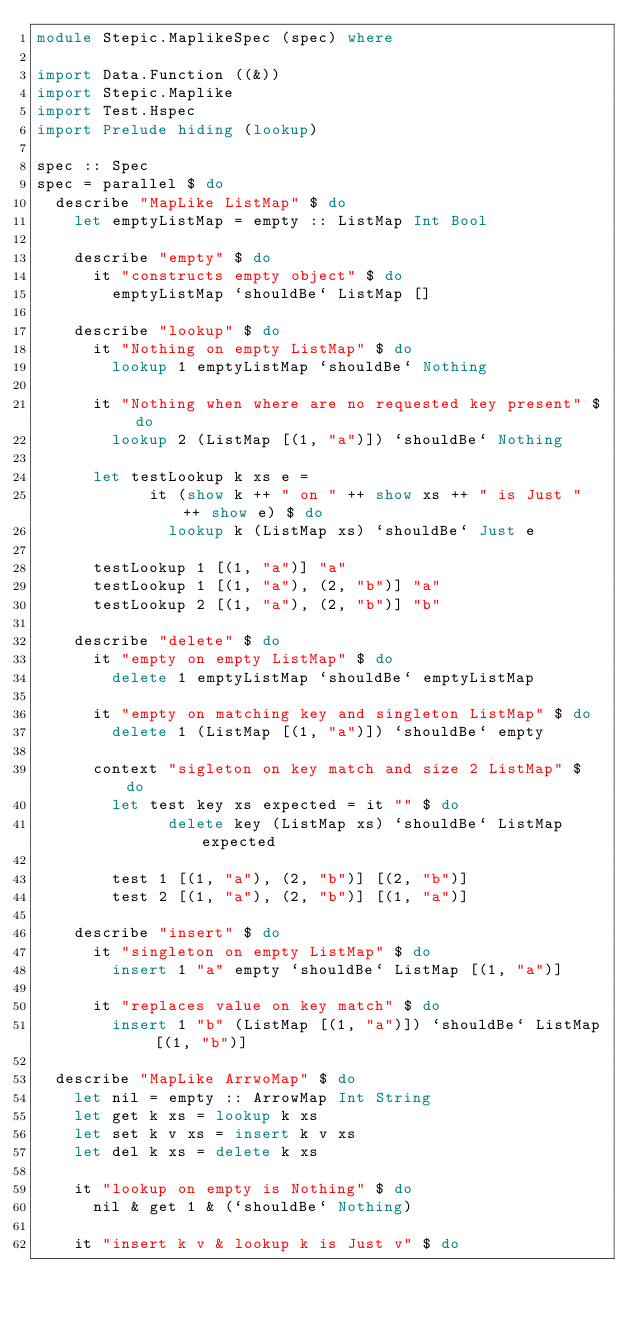Convert code to text. <code><loc_0><loc_0><loc_500><loc_500><_Haskell_>module Stepic.MaplikeSpec (spec) where

import Data.Function ((&))
import Stepic.Maplike
import Test.Hspec
import Prelude hiding (lookup)

spec :: Spec
spec = parallel $ do
  describe "MapLike ListMap" $ do
    let emptyListMap = empty :: ListMap Int Bool

    describe "empty" $ do
      it "constructs empty object" $ do
        emptyListMap `shouldBe` ListMap []

    describe "lookup" $ do
      it "Nothing on empty ListMap" $ do
        lookup 1 emptyListMap `shouldBe` Nothing

      it "Nothing when where are no requested key present" $ do
        lookup 2 (ListMap [(1, "a")]) `shouldBe` Nothing

      let testLookup k xs e =
            it (show k ++ " on " ++ show xs ++ " is Just " ++ show e) $ do
              lookup k (ListMap xs) `shouldBe` Just e

      testLookup 1 [(1, "a")] "a"
      testLookup 1 [(1, "a"), (2, "b")] "a"
      testLookup 2 [(1, "a"), (2, "b")] "b"

    describe "delete" $ do
      it "empty on empty ListMap" $ do
        delete 1 emptyListMap `shouldBe` emptyListMap

      it "empty on matching key and singleton ListMap" $ do
        delete 1 (ListMap [(1, "a")]) `shouldBe` empty

      context "sigleton on key match and size 2 ListMap" $ do
        let test key xs expected = it "" $ do
              delete key (ListMap xs) `shouldBe` ListMap expected

        test 1 [(1, "a"), (2, "b")] [(2, "b")]
        test 2 [(1, "a"), (2, "b")] [(1, "a")]

    describe "insert" $ do
      it "singleton on empty ListMap" $ do
        insert 1 "a" empty `shouldBe` ListMap [(1, "a")]

      it "replaces value on key match" $ do
        insert 1 "b" (ListMap [(1, "a")]) `shouldBe` ListMap [(1, "b")]

  describe "MapLike ArrwoMap" $ do
    let nil = empty :: ArrowMap Int String
    let get k xs = lookup k xs
    let set k v xs = insert k v xs
    let del k xs = delete k xs

    it "lookup on empty is Nothing" $ do
      nil & get 1 & (`shouldBe` Nothing)

    it "insert k v & lookup k is Just v" $ do</code> 